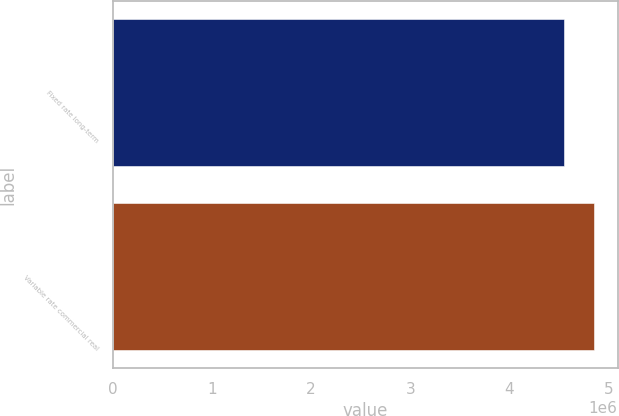Convert chart to OTSL. <chart><loc_0><loc_0><loc_500><loc_500><bar_chart><fcel>Fixed rate long-term<fcel>Variable rate commercial real<nl><fcel>4.55e+06<fcel>4.85e+06<nl></chart> 